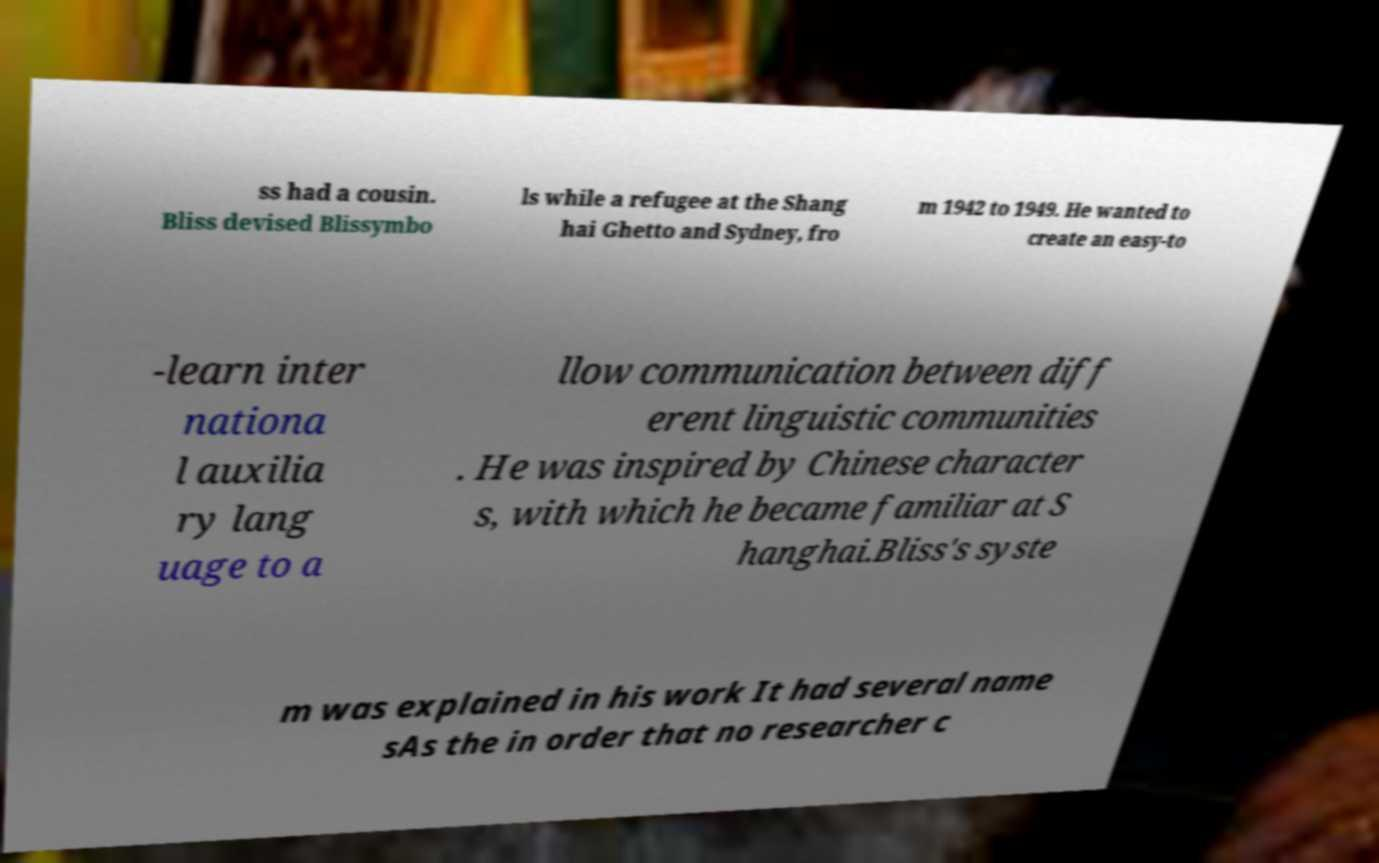For documentation purposes, I need the text within this image transcribed. Could you provide that? ss had a cousin. Bliss devised Blissymbo ls while a refugee at the Shang hai Ghetto and Sydney, fro m 1942 to 1949. He wanted to create an easy-to -learn inter nationa l auxilia ry lang uage to a llow communication between diff erent linguistic communities . He was inspired by Chinese character s, with which he became familiar at S hanghai.Bliss's syste m was explained in his work It had several name sAs the in order that no researcher c 